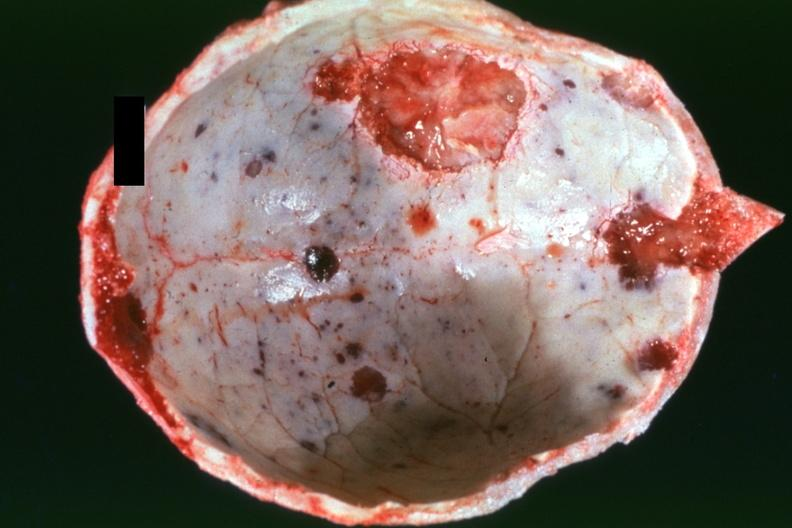s bone, calvarium present?
Answer the question using a single word or phrase. Yes 